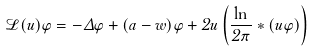Convert formula to latex. <formula><loc_0><loc_0><loc_500><loc_500>\mathcal { L } ( u ) \varphi = - \Delta \varphi + ( a - w ) \varphi + 2 u \left ( \frac { \ln } { 2 \pi } \ast ( u \varphi ) \right )</formula> 